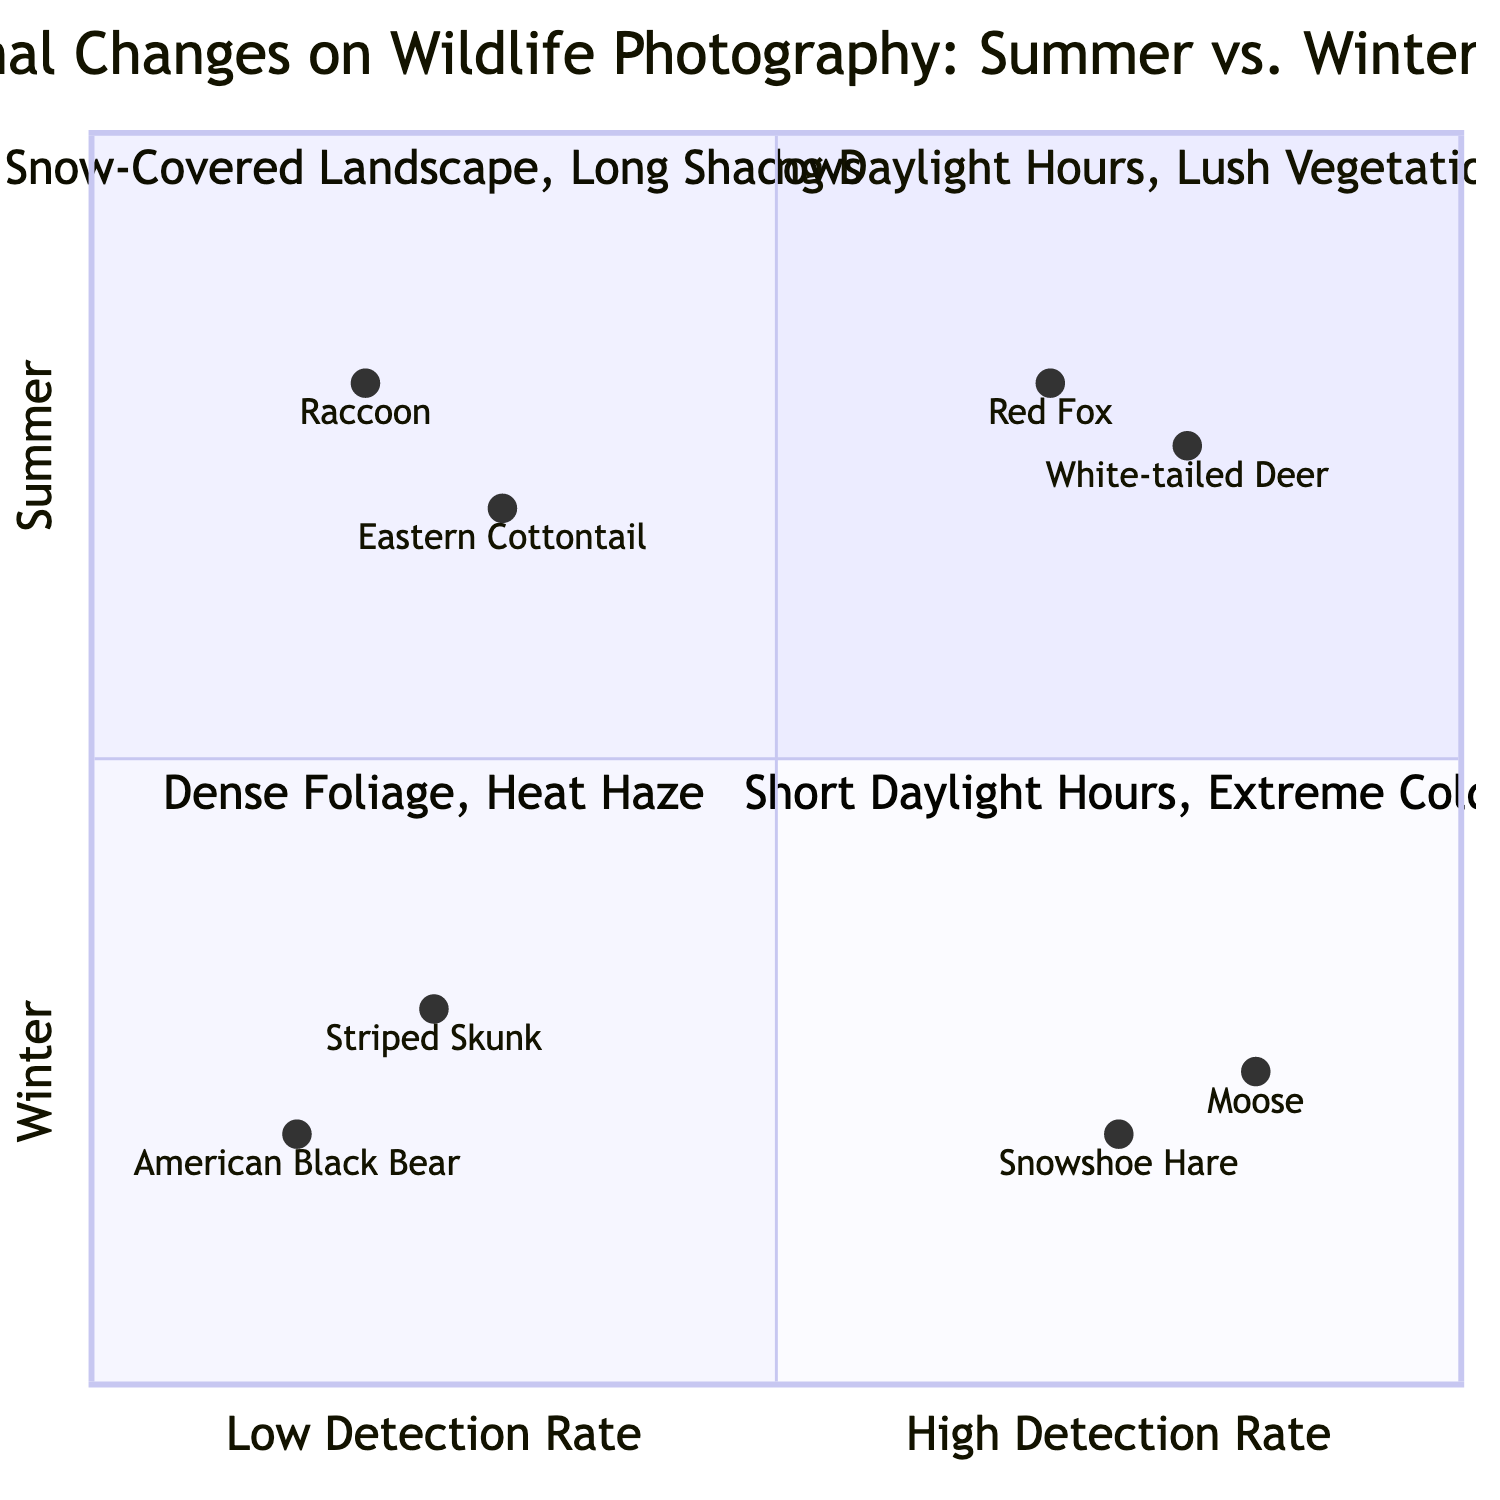What is an example species in the Summer high detection rate quadrant? In the Upper-left quadrant labeled "Summer" with "High Detection Rate," the example species listed is "Red Fox."
Answer: Red Fox Which quadrant contains species with a low detection rate during winter? The Lower-right quadrant represents "Low Detection Rate" in "Winter," containing species such as "Striped Skunk" and "American Black Bear."
Answer: Lower-right What are the photography conditions for the Summer low detection rate quadrant? The Lower-left quadrant describes the conditions for "Low Detection Rate" in "Summer," which are "Dense Foliage" and "Heat Haze."
Answer: Dense Foliage, Heat Haze How many species are listed for the Winter high detection rate quadrant? In the Upper-right quadrant, there are two example species mentioned: "Snowshoe Hare" and "Moose," indicating that the count of species is two.
Answer: 2 Which season has a high detection rate for "White-tailed Deer"? The species "White-tailed Deer" is found in the Upper-left quadrant, which corresponds to "Summer" and has "High Detection Rate."
Answer: Summer What is the common photography condition in the Winter high detection rate quadrant? In the Upper-right quadrant, the common photography conditions are "Snow-Covered Landscape" and "Long Shadows," both listed for this section.
Answer: Snow-Covered Landscape, Long Shadows Which species has the lowest detection rate, according to the diagram? The species with the lowest detection rate is "American Black Bear," located in the Lower-right quadrant where "Low Detection Rate" is applicable for Winter.
Answer: American Black Bear What is the relationship between "Dense Foliage" and detection rates? "Dense Foliage" is listed in the Lower-left quadrant, indicating conditions associated with "Low Detection Rate" for the Summer season, establishing a relationship where this condition negatively affects detection.
Answer: Low Detection Rate Which detection rate is associated with "Snowshoe Hare"? "Snowshoe Hare" is found in the Upper-right quadrant where "High Detection Rate" is applicable for the Winter season.
Answer: High Detection Rate 